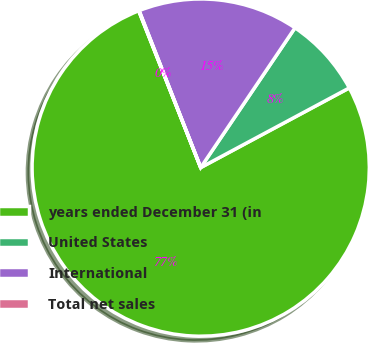Convert chart. <chart><loc_0><loc_0><loc_500><loc_500><pie_chart><fcel>years ended December 31 (in<fcel>United States<fcel>International<fcel>Total net sales<nl><fcel>76.84%<fcel>7.72%<fcel>15.4%<fcel>0.04%<nl></chart> 